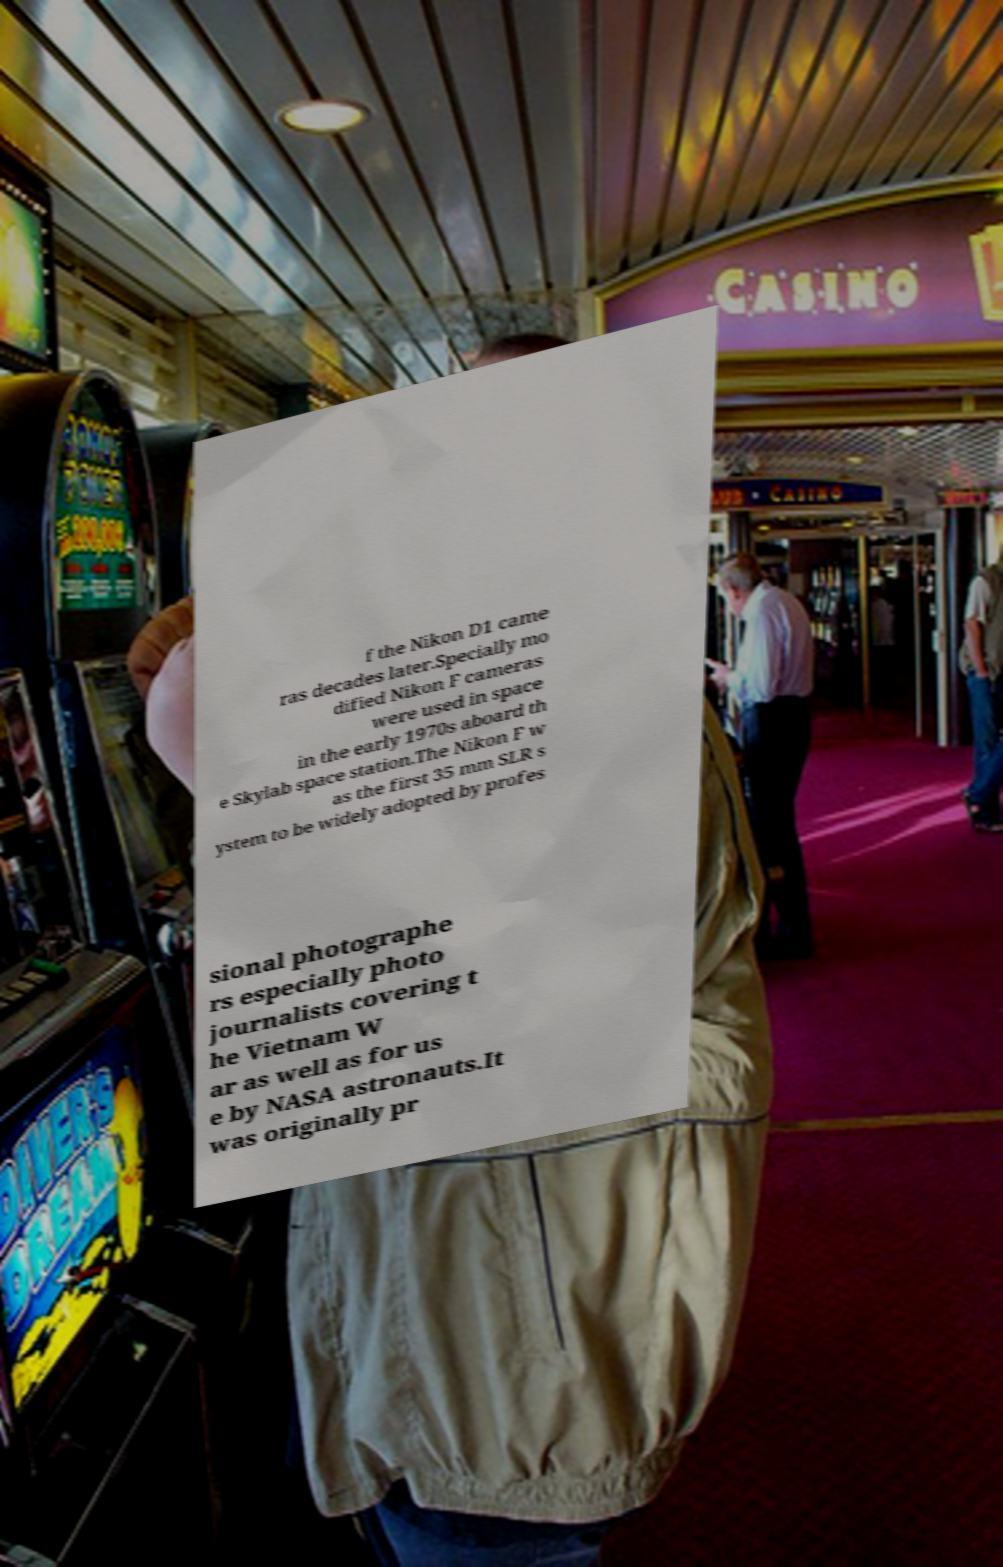For documentation purposes, I need the text within this image transcribed. Could you provide that? f the Nikon D1 came ras decades later.Specially mo dified Nikon F cameras were used in space in the early 1970s aboard th e Skylab space station.The Nikon F w as the first 35 mm SLR s ystem to be widely adopted by profes sional photographe rs especially photo journalists covering t he Vietnam W ar as well as for us e by NASA astronauts.It was originally pr 